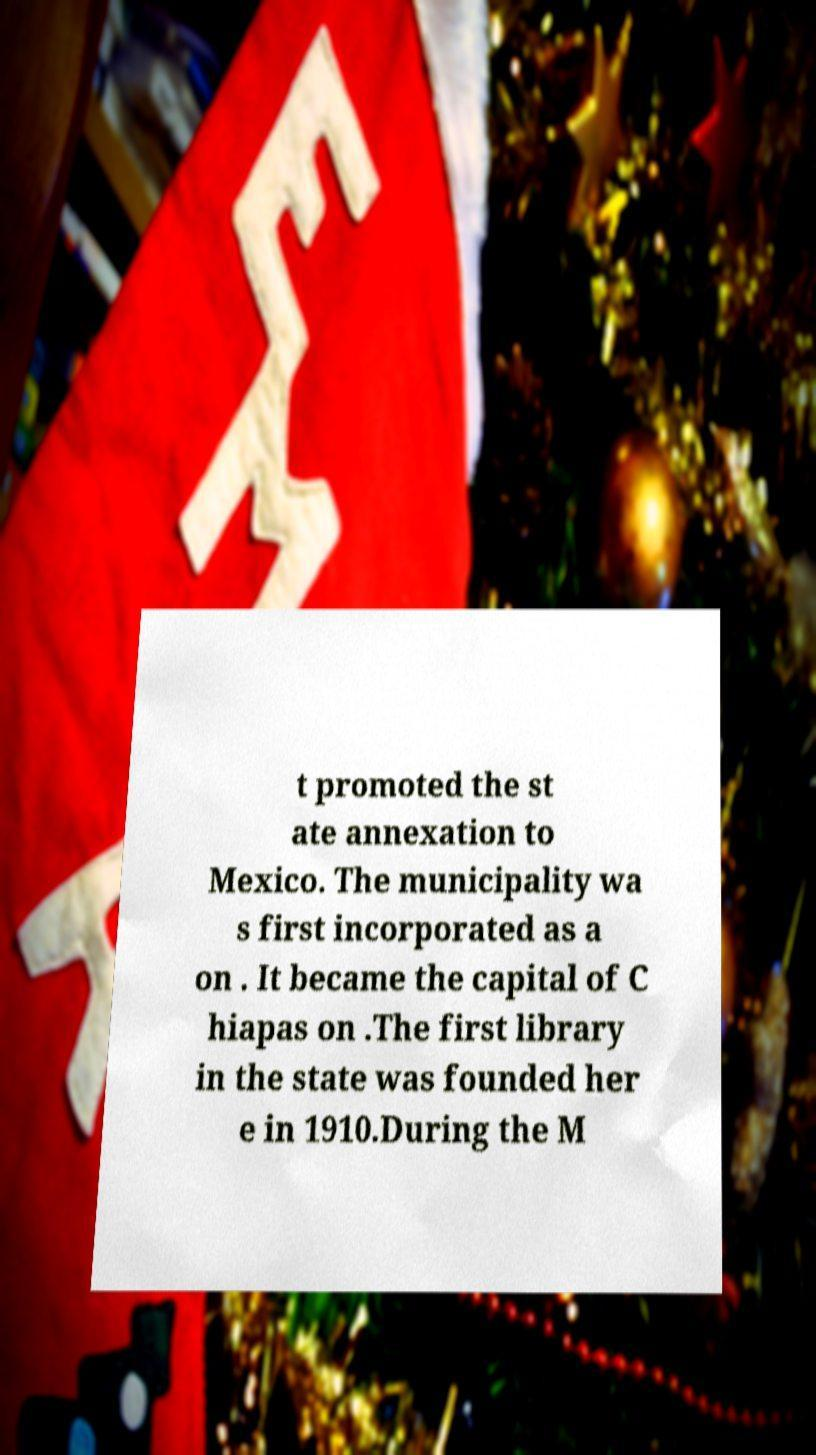What messages or text are displayed in this image? I need them in a readable, typed format. t promoted the st ate annexation to Mexico. The municipality wa s first incorporated as a on . It became the capital of C hiapas on .The first library in the state was founded her e in 1910.During the M 